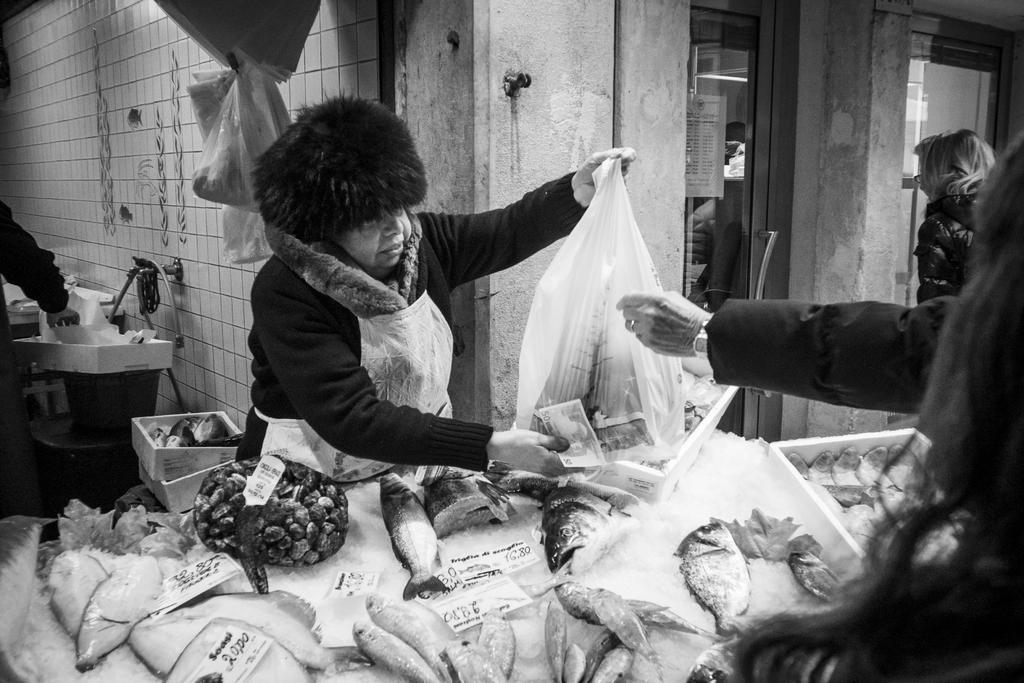How would you summarize this image in a sentence or two? In this picture I can see there is a woman standing and she is holding money and a carry bag, there is a table in front of her, with ice and fishes. There is a person standing at the right side. There is a wall and a few other boxes in the backdrop, there is a woman walking at the right side. 